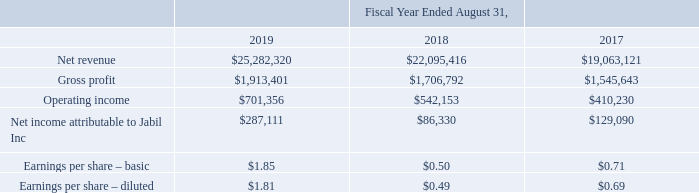Summary of Results
The following table sets forth, for the periods indicated, certain key operating results and other financial information (in thousands, except per share data):
What was the net revenue in 2019?
Answer scale should be: thousand. $25,282,320. What was the gross profit in 2018?
Answer scale should be: thousand. $1,706,792. What was the operating income in 2017?
Answer scale should be: thousand. $410,230. How many years did the net revenue exceed $20,000,000 thousand? 2019##2018
Answer: 2. What was the change in gross profit between 2017 and 2018?
Answer scale should be: thousand. $1,706,792-$1,545,643
Answer: 161149. What was the percentage change in operating income between 2018 and 2019?
Answer scale should be: percent. ($701,356-$542,153)/$542,153
Answer: 29.36. 